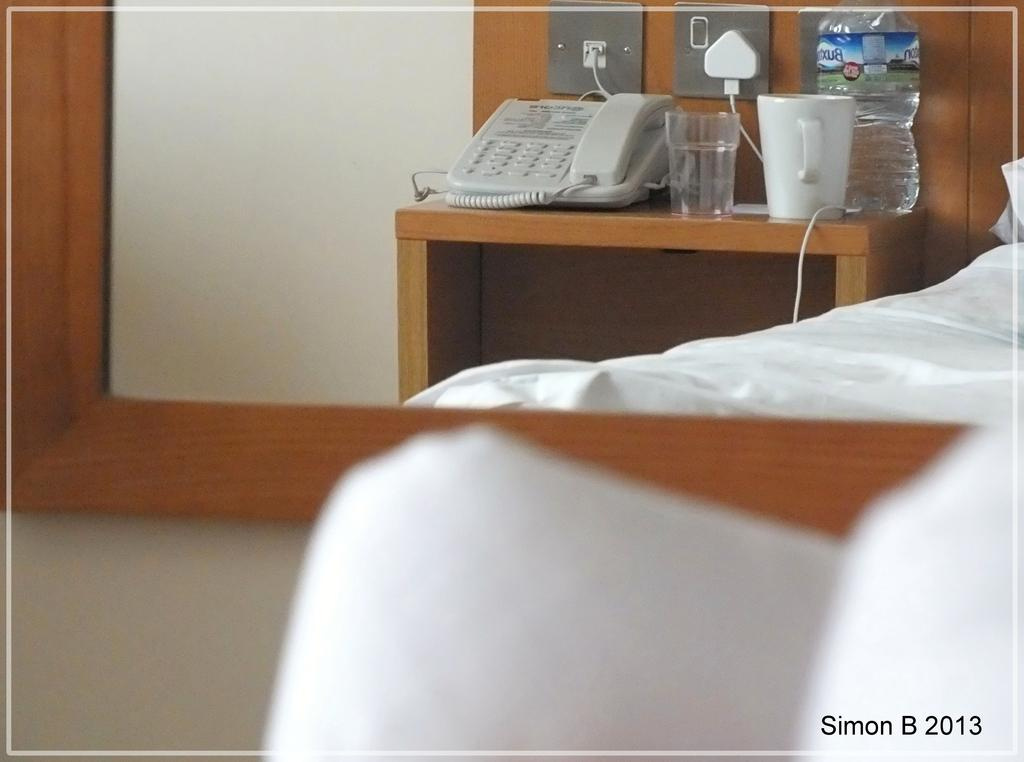What object is reflecting the other items in the image? There is a mirror in the image that reflects the other objects. What can be seen through the mirror? A telephone, a glass, a cup, and a water bottle are visible through the mirror. Where are these objects placed? They are placed on a desk. What other piece of furniture is present in the image? There is a bed in the image. What type of wax is being used to create fear in the image? There is no wax or fear present in the image; it features a mirror reflecting objects on a desk and a bed. 